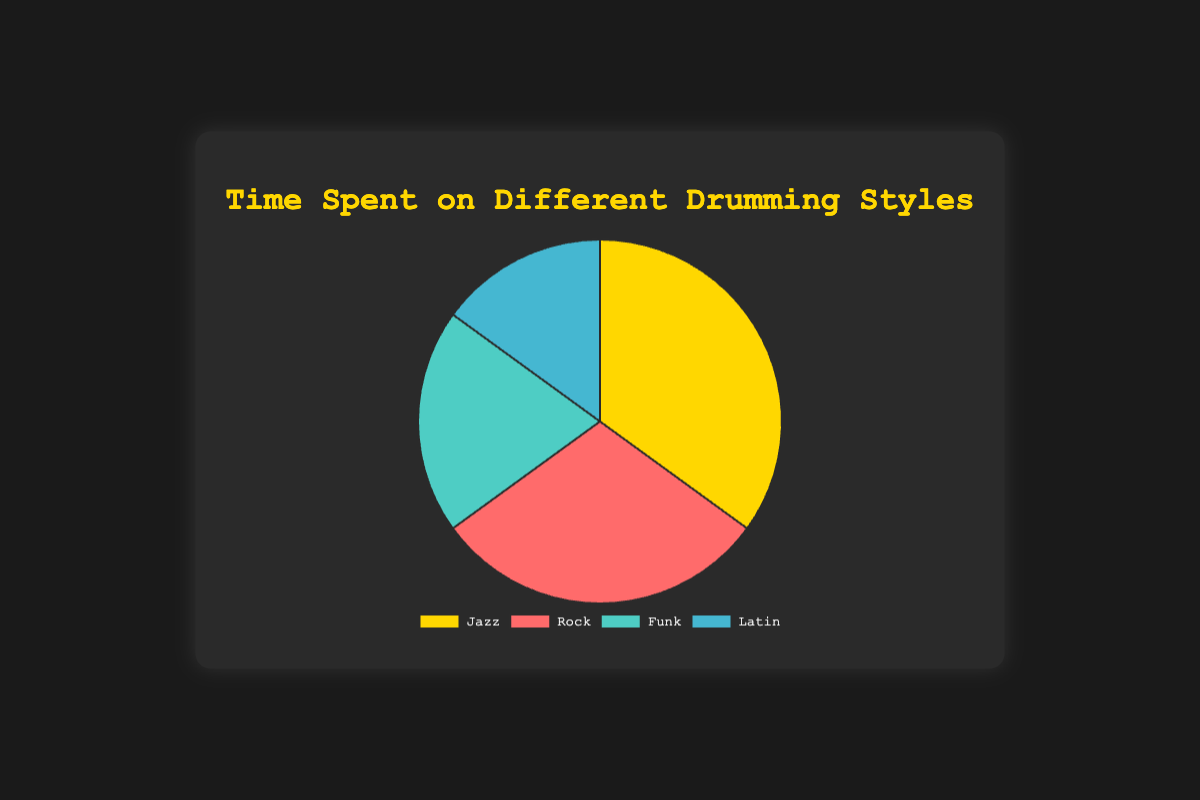What percentage of the total time is spent on Jazz and Rock combined? To find the total percentage spent on Jazz and Rock, simply add the individual percentages: Jazz (35%) and Rock (30%). Therefore, 35% + 30% = 65%.
Answer: 65% Which drumming style takes up the least amount of time? The pie chart shows the time spent on each drumming style in percentages. Latin has the lowest percentage at 15%.
Answer: Latin What is the difference in time spent between the style with the highest and the one with the lowest percentage? The highest percentage is for Jazz at 35%, and the lowest is for Latin at 15%. The difference is calculated by subtracting the lower percentage from the higher one: 35% - 15% = 20%.
Answer: 20% What is the average percentage of time spent across all the drumming styles? To find the average, sum all the percentages and then divide by the total number of styles. The sum is 35% (Jazz) + 30% (Rock) + 20% (Funk) + 15% (Latin) = 100%. Dividing by 4 styles, 100% / 4 = 25%.
Answer: 25% How much more time is spent on Jazz compared to Funk? Jazz accounts for 35% of the time, while Funk accounts for 20%. The difference is 35% - 20% = 15%.
Answer: 15% Which two drumming styles have a combined percentage that is less than the percentage of Jazz alone? Jazz has 35%. The combined percentage of any two styles should be less than this. The possible pairs are Rock (30%) + Latin (15%) = 45%, Funk (20%) + Latin (15%) = 35%, Rock (30%) + Funk (20%) = 50%, Jazz (35%) + any style would be greater than 35%. Therefore, none of the combinations are correct.
Answer: None Which segment is represented by a golden color? The golden color represents the Jazz style, as depicted in the pie chart legend.
Answer: Jazz If you were to re-arrange the styles in descending order of time spent, what would be the sequence? From the chart, arrange the styles by their time spent percentages: Jazz (35%), Rock (30%), Funk (20%), Latin (15%).
Answer: Jazz, Rock, Funk, Latin 